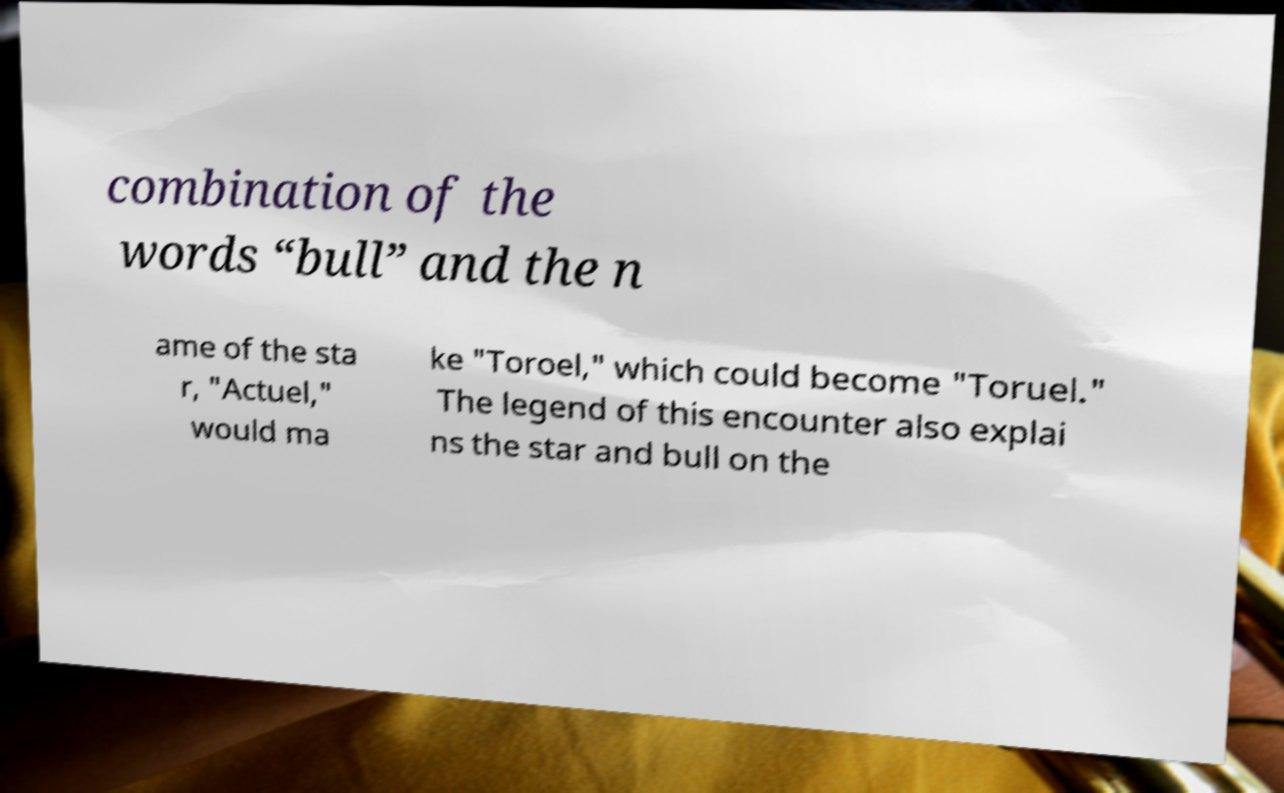Could you assist in decoding the text presented in this image and type it out clearly? combination of the words “bull” and the n ame of the sta r, "Actuel," would ma ke "Toroel," which could become "Toruel." The legend of this encounter also explai ns the star and bull on the 